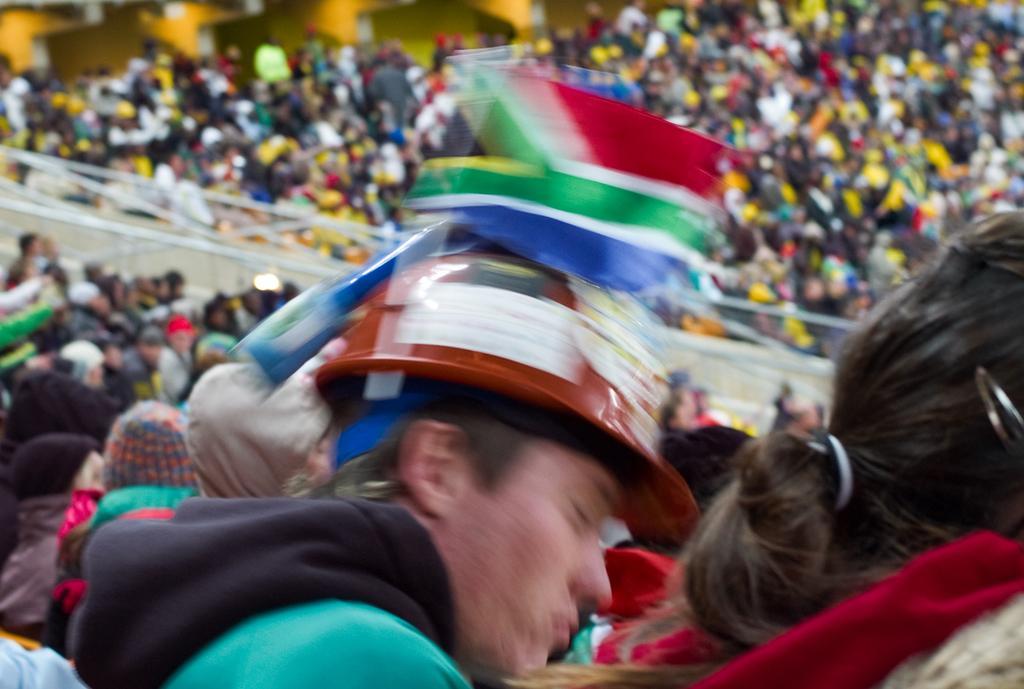Please provide a concise description of this image. In this image I can see the group of people with different color dresses. I can see few people with caps. These people are to the side of the white color railing. In the back I can see few more people but it is blurry. 